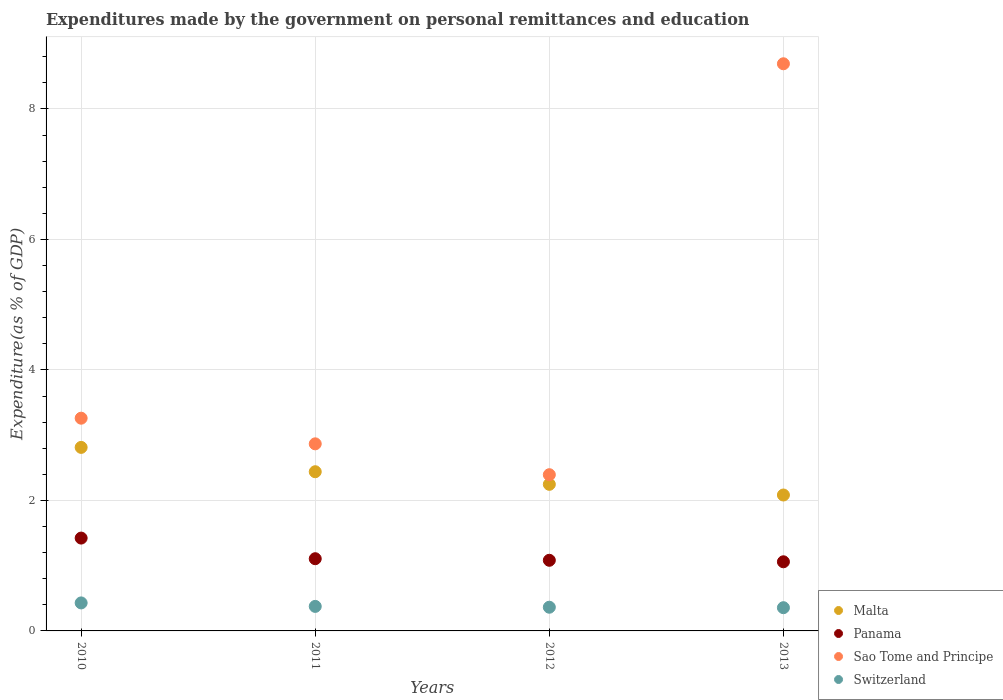How many different coloured dotlines are there?
Make the answer very short. 4. What is the expenditures made by the government on personal remittances and education in Panama in 2010?
Provide a succinct answer. 1.42. Across all years, what is the maximum expenditures made by the government on personal remittances and education in Switzerland?
Give a very brief answer. 0.43. Across all years, what is the minimum expenditures made by the government on personal remittances and education in Malta?
Make the answer very short. 2.08. In which year was the expenditures made by the government on personal remittances and education in Switzerland minimum?
Make the answer very short. 2013. What is the total expenditures made by the government on personal remittances and education in Sao Tome and Principe in the graph?
Provide a succinct answer. 17.21. What is the difference between the expenditures made by the government on personal remittances and education in Switzerland in 2010 and that in 2011?
Your answer should be very brief. 0.05. What is the difference between the expenditures made by the government on personal remittances and education in Malta in 2011 and the expenditures made by the government on personal remittances and education in Switzerland in 2010?
Give a very brief answer. 2.01. What is the average expenditures made by the government on personal remittances and education in Switzerland per year?
Provide a succinct answer. 0.38. In the year 2013, what is the difference between the expenditures made by the government on personal remittances and education in Malta and expenditures made by the government on personal remittances and education in Switzerland?
Offer a very short reply. 1.73. What is the ratio of the expenditures made by the government on personal remittances and education in Malta in 2010 to that in 2012?
Provide a short and direct response. 1.25. Is the expenditures made by the government on personal remittances and education in Panama in 2012 less than that in 2013?
Offer a very short reply. No. Is the difference between the expenditures made by the government on personal remittances and education in Malta in 2011 and 2013 greater than the difference between the expenditures made by the government on personal remittances and education in Switzerland in 2011 and 2013?
Provide a short and direct response. Yes. What is the difference between the highest and the second highest expenditures made by the government on personal remittances and education in Malta?
Make the answer very short. 0.37. What is the difference between the highest and the lowest expenditures made by the government on personal remittances and education in Malta?
Your answer should be compact. 0.73. Is the expenditures made by the government on personal remittances and education in Malta strictly greater than the expenditures made by the government on personal remittances and education in Sao Tome and Principe over the years?
Keep it short and to the point. No. How many years are there in the graph?
Your answer should be very brief. 4. What is the difference between two consecutive major ticks on the Y-axis?
Your answer should be compact. 2. Where does the legend appear in the graph?
Your response must be concise. Bottom right. What is the title of the graph?
Offer a very short reply. Expenditures made by the government on personal remittances and education. What is the label or title of the X-axis?
Provide a succinct answer. Years. What is the label or title of the Y-axis?
Offer a terse response. Expenditure(as % of GDP). What is the Expenditure(as % of GDP) of Malta in 2010?
Give a very brief answer. 2.81. What is the Expenditure(as % of GDP) of Panama in 2010?
Offer a very short reply. 1.42. What is the Expenditure(as % of GDP) of Sao Tome and Principe in 2010?
Offer a very short reply. 3.26. What is the Expenditure(as % of GDP) of Switzerland in 2010?
Offer a very short reply. 0.43. What is the Expenditure(as % of GDP) in Malta in 2011?
Give a very brief answer. 2.44. What is the Expenditure(as % of GDP) of Panama in 2011?
Provide a short and direct response. 1.11. What is the Expenditure(as % of GDP) of Sao Tome and Principe in 2011?
Offer a terse response. 2.87. What is the Expenditure(as % of GDP) in Switzerland in 2011?
Offer a terse response. 0.38. What is the Expenditure(as % of GDP) of Malta in 2012?
Offer a very short reply. 2.25. What is the Expenditure(as % of GDP) in Panama in 2012?
Provide a succinct answer. 1.08. What is the Expenditure(as % of GDP) of Sao Tome and Principe in 2012?
Your answer should be compact. 2.39. What is the Expenditure(as % of GDP) of Switzerland in 2012?
Your response must be concise. 0.36. What is the Expenditure(as % of GDP) in Malta in 2013?
Provide a short and direct response. 2.08. What is the Expenditure(as % of GDP) of Panama in 2013?
Provide a short and direct response. 1.06. What is the Expenditure(as % of GDP) of Sao Tome and Principe in 2013?
Keep it short and to the point. 8.69. What is the Expenditure(as % of GDP) in Switzerland in 2013?
Your answer should be very brief. 0.36. Across all years, what is the maximum Expenditure(as % of GDP) in Malta?
Give a very brief answer. 2.81. Across all years, what is the maximum Expenditure(as % of GDP) of Panama?
Offer a very short reply. 1.42. Across all years, what is the maximum Expenditure(as % of GDP) in Sao Tome and Principe?
Provide a succinct answer. 8.69. Across all years, what is the maximum Expenditure(as % of GDP) in Switzerland?
Keep it short and to the point. 0.43. Across all years, what is the minimum Expenditure(as % of GDP) of Malta?
Offer a terse response. 2.08. Across all years, what is the minimum Expenditure(as % of GDP) of Panama?
Provide a short and direct response. 1.06. Across all years, what is the minimum Expenditure(as % of GDP) in Sao Tome and Principe?
Ensure brevity in your answer.  2.39. Across all years, what is the minimum Expenditure(as % of GDP) of Switzerland?
Provide a short and direct response. 0.36. What is the total Expenditure(as % of GDP) in Malta in the graph?
Provide a succinct answer. 9.58. What is the total Expenditure(as % of GDP) in Panama in the graph?
Give a very brief answer. 4.67. What is the total Expenditure(as % of GDP) of Sao Tome and Principe in the graph?
Keep it short and to the point. 17.21. What is the total Expenditure(as % of GDP) of Switzerland in the graph?
Your answer should be compact. 1.52. What is the difference between the Expenditure(as % of GDP) of Malta in 2010 and that in 2011?
Keep it short and to the point. 0.37. What is the difference between the Expenditure(as % of GDP) of Panama in 2010 and that in 2011?
Provide a succinct answer. 0.32. What is the difference between the Expenditure(as % of GDP) in Sao Tome and Principe in 2010 and that in 2011?
Your answer should be compact. 0.39. What is the difference between the Expenditure(as % of GDP) of Switzerland in 2010 and that in 2011?
Offer a very short reply. 0.05. What is the difference between the Expenditure(as % of GDP) of Malta in 2010 and that in 2012?
Provide a succinct answer. 0.57. What is the difference between the Expenditure(as % of GDP) in Panama in 2010 and that in 2012?
Provide a succinct answer. 0.34. What is the difference between the Expenditure(as % of GDP) in Sao Tome and Principe in 2010 and that in 2012?
Ensure brevity in your answer.  0.87. What is the difference between the Expenditure(as % of GDP) of Switzerland in 2010 and that in 2012?
Your answer should be compact. 0.07. What is the difference between the Expenditure(as % of GDP) of Malta in 2010 and that in 2013?
Offer a very short reply. 0.73. What is the difference between the Expenditure(as % of GDP) of Panama in 2010 and that in 2013?
Your answer should be compact. 0.36. What is the difference between the Expenditure(as % of GDP) of Sao Tome and Principe in 2010 and that in 2013?
Give a very brief answer. -5.43. What is the difference between the Expenditure(as % of GDP) in Switzerland in 2010 and that in 2013?
Provide a succinct answer. 0.07. What is the difference between the Expenditure(as % of GDP) of Malta in 2011 and that in 2012?
Your answer should be very brief. 0.19. What is the difference between the Expenditure(as % of GDP) of Panama in 2011 and that in 2012?
Provide a short and direct response. 0.02. What is the difference between the Expenditure(as % of GDP) of Sao Tome and Principe in 2011 and that in 2012?
Your answer should be compact. 0.47. What is the difference between the Expenditure(as % of GDP) in Switzerland in 2011 and that in 2012?
Give a very brief answer. 0.01. What is the difference between the Expenditure(as % of GDP) of Malta in 2011 and that in 2013?
Offer a terse response. 0.36. What is the difference between the Expenditure(as % of GDP) of Panama in 2011 and that in 2013?
Ensure brevity in your answer.  0.05. What is the difference between the Expenditure(as % of GDP) in Sao Tome and Principe in 2011 and that in 2013?
Provide a short and direct response. -5.83. What is the difference between the Expenditure(as % of GDP) in Switzerland in 2011 and that in 2013?
Your answer should be compact. 0.02. What is the difference between the Expenditure(as % of GDP) in Malta in 2012 and that in 2013?
Keep it short and to the point. 0.16. What is the difference between the Expenditure(as % of GDP) of Panama in 2012 and that in 2013?
Your answer should be very brief. 0.02. What is the difference between the Expenditure(as % of GDP) of Sao Tome and Principe in 2012 and that in 2013?
Offer a terse response. -6.3. What is the difference between the Expenditure(as % of GDP) of Switzerland in 2012 and that in 2013?
Your answer should be very brief. 0.01. What is the difference between the Expenditure(as % of GDP) of Malta in 2010 and the Expenditure(as % of GDP) of Panama in 2011?
Provide a short and direct response. 1.71. What is the difference between the Expenditure(as % of GDP) in Malta in 2010 and the Expenditure(as % of GDP) in Sao Tome and Principe in 2011?
Your response must be concise. -0.05. What is the difference between the Expenditure(as % of GDP) in Malta in 2010 and the Expenditure(as % of GDP) in Switzerland in 2011?
Keep it short and to the point. 2.44. What is the difference between the Expenditure(as % of GDP) of Panama in 2010 and the Expenditure(as % of GDP) of Sao Tome and Principe in 2011?
Provide a succinct answer. -1.44. What is the difference between the Expenditure(as % of GDP) of Panama in 2010 and the Expenditure(as % of GDP) of Switzerland in 2011?
Provide a short and direct response. 1.05. What is the difference between the Expenditure(as % of GDP) of Sao Tome and Principe in 2010 and the Expenditure(as % of GDP) of Switzerland in 2011?
Provide a succinct answer. 2.88. What is the difference between the Expenditure(as % of GDP) in Malta in 2010 and the Expenditure(as % of GDP) in Panama in 2012?
Provide a short and direct response. 1.73. What is the difference between the Expenditure(as % of GDP) in Malta in 2010 and the Expenditure(as % of GDP) in Sao Tome and Principe in 2012?
Your answer should be compact. 0.42. What is the difference between the Expenditure(as % of GDP) in Malta in 2010 and the Expenditure(as % of GDP) in Switzerland in 2012?
Offer a terse response. 2.45. What is the difference between the Expenditure(as % of GDP) in Panama in 2010 and the Expenditure(as % of GDP) in Sao Tome and Principe in 2012?
Your answer should be compact. -0.97. What is the difference between the Expenditure(as % of GDP) of Panama in 2010 and the Expenditure(as % of GDP) of Switzerland in 2012?
Your answer should be compact. 1.06. What is the difference between the Expenditure(as % of GDP) of Sao Tome and Principe in 2010 and the Expenditure(as % of GDP) of Switzerland in 2012?
Offer a terse response. 2.9. What is the difference between the Expenditure(as % of GDP) of Malta in 2010 and the Expenditure(as % of GDP) of Panama in 2013?
Give a very brief answer. 1.75. What is the difference between the Expenditure(as % of GDP) of Malta in 2010 and the Expenditure(as % of GDP) of Sao Tome and Principe in 2013?
Ensure brevity in your answer.  -5.88. What is the difference between the Expenditure(as % of GDP) in Malta in 2010 and the Expenditure(as % of GDP) in Switzerland in 2013?
Give a very brief answer. 2.46. What is the difference between the Expenditure(as % of GDP) of Panama in 2010 and the Expenditure(as % of GDP) of Sao Tome and Principe in 2013?
Your answer should be very brief. -7.27. What is the difference between the Expenditure(as % of GDP) in Panama in 2010 and the Expenditure(as % of GDP) in Switzerland in 2013?
Ensure brevity in your answer.  1.07. What is the difference between the Expenditure(as % of GDP) of Sao Tome and Principe in 2010 and the Expenditure(as % of GDP) of Switzerland in 2013?
Provide a short and direct response. 2.9. What is the difference between the Expenditure(as % of GDP) in Malta in 2011 and the Expenditure(as % of GDP) in Panama in 2012?
Your answer should be very brief. 1.36. What is the difference between the Expenditure(as % of GDP) in Malta in 2011 and the Expenditure(as % of GDP) in Sao Tome and Principe in 2012?
Your response must be concise. 0.05. What is the difference between the Expenditure(as % of GDP) of Malta in 2011 and the Expenditure(as % of GDP) of Switzerland in 2012?
Your answer should be compact. 2.08. What is the difference between the Expenditure(as % of GDP) of Panama in 2011 and the Expenditure(as % of GDP) of Sao Tome and Principe in 2012?
Provide a short and direct response. -1.29. What is the difference between the Expenditure(as % of GDP) in Panama in 2011 and the Expenditure(as % of GDP) in Switzerland in 2012?
Give a very brief answer. 0.74. What is the difference between the Expenditure(as % of GDP) of Sao Tome and Principe in 2011 and the Expenditure(as % of GDP) of Switzerland in 2012?
Offer a terse response. 2.5. What is the difference between the Expenditure(as % of GDP) of Malta in 2011 and the Expenditure(as % of GDP) of Panama in 2013?
Ensure brevity in your answer.  1.38. What is the difference between the Expenditure(as % of GDP) of Malta in 2011 and the Expenditure(as % of GDP) of Sao Tome and Principe in 2013?
Ensure brevity in your answer.  -6.25. What is the difference between the Expenditure(as % of GDP) in Malta in 2011 and the Expenditure(as % of GDP) in Switzerland in 2013?
Your answer should be compact. 2.08. What is the difference between the Expenditure(as % of GDP) of Panama in 2011 and the Expenditure(as % of GDP) of Sao Tome and Principe in 2013?
Your answer should be very brief. -7.59. What is the difference between the Expenditure(as % of GDP) in Panama in 2011 and the Expenditure(as % of GDP) in Switzerland in 2013?
Give a very brief answer. 0.75. What is the difference between the Expenditure(as % of GDP) of Sao Tome and Principe in 2011 and the Expenditure(as % of GDP) of Switzerland in 2013?
Offer a very short reply. 2.51. What is the difference between the Expenditure(as % of GDP) in Malta in 2012 and the Expenditure(as % of GDP) in Panama in 2013?
Your response must be concise. 1.19. What is the difference between the Expenditure(as % of GDP) in Malta in 2012 and the Expenditure(as % of GDP) in Sao Tome and Principe in 2013?
Keep it short and to the point. -6.45. What is the difference between the Expenditure(as % of GDP) of Malta in 2012 and the Expenditure(as % of GDP) of Switzerland in 2013?
Your answer should be compact. 1.89. What is the difference between the Expenditure(as % of GDP) of Panama in 2012 and the Expenditure(as % of GDP) of Sao Tome and Principe in 2013?
Provide a short and direct response. -7.61. What is the difference between the Expenditure(as % of GDP) of Panama in 2012 and the Expenditure(as % of GDP) of Switzerland in 2013?
Your answer should be very brief. 0.73. What is the difference between the Expenditure(as % of GDP) of Sao Tome and Principe in 2012 and the Expenditure(as % of GDP) of Switzerland in 2013?
Provide a short and direct response. 2.04. What is the average Expenditure(as % of GDP) of Malta per year?
Keep it short and to the point. 2.4. What is the average Expenditure(as % of GDP) in Panama per year?
Provide a short and direct response. 1.17. What is the average Expenditure(as % of GDP) in Sao Tome and Principe per year?
Provide a succinct answer. 4.3. What is the average Expenditure(as % of GDP) of Switzerland per year?
Ensure brevity in your answer.  0.38. In the year 2010, what is the difference between the Expenditure(as % of GDP) of Malta and Expenditure(as % of GDP) of Panama?
Your answer should be compact. 1.39. In the year 2010, what is the difference between the Expenditure(as % of GDP) of Malta and Expenditure(as % of GDP) of Sao Tome and Principe?
Provide a short and direct response. -0.45. In the year 2010, what is the difference between the Expenditure(as % of GDP) in Malta and Expenditure(as % of GDP) in Switzerland?
Your answer should be very brief. 2.38. In the year 2010, what is the difference between the Expenditure(as % of GDP) of Panama and Expenditure(as % of GDP) of Sao Tome and Principe?
Offer a very short reply. -1.84. In the year 2010, what is the difference between the Expenditure(as % of GDP) in Panama and Expenditure(as % of GDP) in Switzerland?
Your answer should be very brief. 0.99. In the year 2010, what is the difference between the Expenditure(as % of GDP) of Sao Tome and Principe and Expenditure(as % of GDP) of Switzerland?
Your response must be concise. 2.83. In the year 2011, what is the difference between the Expenditure(as % of GDP) of Malta and Expenditure(as % of GDP) of Panama?
Your response must be concise. 1.33. In the year 2011, what is the difference between the Expenditure(as % of GDP) in Malta and Expenditure(as % of GDP) in Sao Tome and Principe?
Make the answer very short. -0.43. In the year 2011, what is the difference between the Expenditure(as % of GDP) in Malta and Expenditure(as % of GDP) in Switzerland?
Offer a terse response. 2.06. In the year 2011, what is the difference between the Expenditure(as % of GDP) of Panama and Expenditure(as % of GDP) of Sao Tome and Principe?
Keep it short and to the point. -1.76. In the year 2011, what is the difference between the Expenditure(as % of GDP) in Panama and Expenditure(as % of GDP) in Switzerland?
Give a very brief answer. 0.73. In the year 2011, what is the difference between the Expenditure(as % of GDP) in Sao Tome and Principe and Expenditure(as % of GDP) in Switzerland?
Provide a succinct answer. 2.49. In the year 2012, what is the difference between the Expenditure(as % of GDP) of Malta and Expenditure(as % of GDP) of Panama?
Provide a succinct answer. 1.16. In the year 2012, what is the difference between the Expenditure(as % of GDP) of Malta and Expenditure(as % of GDP) of Sao Tome and Principe?
Ensure brevity in your answer.  -0.15. In the year 2012, what is the difference between the Expenditure(as % of GDP) of Malta and Expenditure(as % of GDP) of Switzerland?
Make the answer very short. 1.88. In the year 2012, what is the difference between the Expenditure(as % of GDP) of Panama and Expenditure(as % of GDP) of Sao Tome and Principe?
Offer a very short reply. -1.31. In the year 2012, what is the difference between the Expenditure(as % of GDP) of Panama and Expenditure(as % of GDP) of Switzerland?
Offer a very short reply. 0.72. In the year 2012, what is the difference between the Expenditure(as % of GDP) of Sao Tome and Principe and Expenditure(as % of GDP) of Switzerland?
Offer a terse response. 2.03. In the year 2013, what is the difference between the Expenditure(as % of GDP) in Malta and Expenditure(as % of GDP) in Panama?
Provide a short and direct response. 1.02. In the year 2013, what is the difference between the Expenditure(as % of GDP) of Malta and Expenditure(as % of GDP) of Sao Tome and Principe?
Keep it short and to the point. -6.61. In the year 2013, what is the difference between the Expenditure(as % of GDP) of Malta and Expenditure(as % of GDP) of Switzerland?
Give a very brief answer. 1.73. In the year 2013, what is the difference between the Expenditure(as % of GDP) in Panama and Expenditure(as % of GDP) in Sao Tome and Principe?
Provide a succinct answer. -7.63. In the year 2013, what is the difference between the Expenditure(as % of GDP) of Panama and Expenditure(as % of GDP) of Switzerland?
Offer a terse response. 0.7. In the year 2013, what is the difference between the Expenditure(as % of GDP) of Sao Tome and Principe and Expenditure(as % of GDP) of Switzerland?
Offer a terse response. 8.34. What is the ratio of the Expenditure(as % of GDP) in Malta in 2010 to that in 2011?
Your answer should be compact. 1.15. What is the ratio of the Expenditure(as % of GDP) in Panama in 2010 to that in 2011?
Provide a succinct answer. 1.29. What is the ratio of the Expenditure(as % of GDP) of Sao Tome and Principe in 2010 to that in 2011?
Provide a short and direct response. 1.14. What is the ratio of the Expenditure(as % of GDP) of Switzerland in 2010 to that in 2011?
Give a very brief answer. 1.14. What is the ratio of the Expenditure(as % of GDP) in Malta in 2010 to that in 2012?
Your answer should be very brief. 1.25. What is the ratio of the Expenditure(as % of GDP) of Panama in 2010 to that in 2012?
Provide a succinct answer. 1.31. What is the ratio of the Expenditure(as % of GDP) of Sao Tome and Principe in 2010 to that in 2012?
Ensure brevity in your answer.  1.36. What is the ratio of the Expenditure(as % of GDP) in Switzerland in 2010 to that in 2012?
Offer a very short reply. 1.18. What is the ratio of the Expenditure(as % of GDP) of Malta in 2010 to that in 2013?
Your answer should be very brief. 1.35. What is the ratio of the Expenditure(as % of GDP) of Panama in 2010 to that in 2013?
Provide a short and direct response. 1.34. What is the ratio of the Expenditure(as % of GDP) in Sao Tome and Principe in 2010 to that in 2013?
Provide a short and direct response. 0.38. What is the ratio of the Expenditure(as % of GDP) in Switzerland in 2010 to that in 2013?
Keep it short and to the point. 1.21. What is the ratio of the Expenditure(as % of GDP) of Malta in 2011 to that in 2012?
Keep it short and to the point. 1.09. What is the ratio of the Expenditure(as % of GDP) of Panama in 2011 to that in 2012?
Offer a very short reply. 1.02. What is the ratio of the Expenditure(as % of GDP) of Sao Tome and Principe in 2011 to that in 2012?
Your answer should be very brief. 1.2. What is the ratio of the Expenditure(as % of GDP) in Switzerland in 2011 to that in 2012?
Offer a very short reply. 1.03. What is the ratio of the Expenditure(as % of GDP) in Malta in 2011 to that in 2013?
Ensure brevity in your answer.  1.17. What is the ratio of the Expenditure(as % of GDP) of Panama in 2011 to that in 2013?
Your answer should be very brief. 1.04. What is the ratio of the Expenditure(as % of GDP) in Sao Tome and Principe in 2011 to that in 2013?
Offer a terse response. 0.33. What is the ratio of the Expenditure(as % of GDP) of Switzerland in 2011 to that in 2013?
Ensure brevity in your answer.  1.06. What is the ratio of the Expenditure(as % of GDP) in Malta in 2012 to that in 2013?
Offer a terse response. 1.08. What is the ratio of the Expenditure(as % of GDP) of Panama in 2012 to that in 2013?
Ensure brevity in your answer.  1.02. What is the ratio of the Expenditure(as % of GDP) in Sao Tome and Principe in 2012 to that in 2013?
Ensure brevity in your answer.  0.28. What is the ratio of the Expenditure(as % of GDP) in Switzerland in 2012 to that in 2013?
Offer a very short reply. 1.02. What is the difference between the highest and the second highest Expenditure(as % of GDP) in Malta?
Your answer should be very brief. 0.37. What is the difference between the highest and the second highest Expenditure(as % of GDP) in Panama?
Give a very brief answer. 0.32. What is the difference between the highest and the second highest Expenditure(as % of GDP) in Sao Tome and Principe?
Your answer should be very brief. 5.43. What is the difference between the highest and the second highest Expenditure(as % of GDP) of Switzerland?
Your answer should be very brief. 0.05. What is the difference between the highest and the lowest Expenditure(as % of GDP) in Malta?
Offer a terse response. 0.73. What is the difference between the highest and the lowest Expenditure(as % of GDP) of Panama?
Ensure brevity in your answer.  0.36. What is the difference between the highest and the lowest Expenditure(as % of GDP) in Sao Tome and Principe?
Ensure brevity in your answer.  6.3. What is the difference between the highest and the lowest Expenditure(as % of GDP) of Switzerland?
Provide a short and direct response. 0.07. 